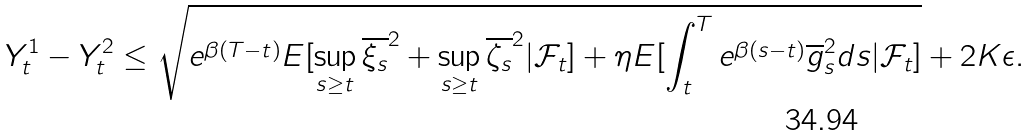Convert formula to latex. <formula><loc_0><loc_0><loc_500><loc_500>Y _ { t } ^ { 1 } - Y _ { t } ^ { 2 } \leq \sqrt { e ^ { \beta ( T - t ) } E [ \sup _ { s \geq t } \overline { \xi _ { s } } ^ { 2 } + \sup _ { s \geq t } \overline { \zeta _ { s } } ^ { 2 } | \mathcal { F } _ { t } ] + \eta E [ \int _ { t } ^ { T } e ^ { \beta ( s - t ) } { \overline { g } _ { s } ^ { 2 } } d s | \mathcal { F } _ { t } ] } + 2 K \epsilon .</formula> 